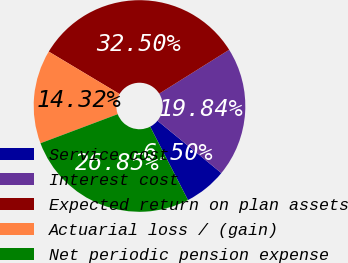Convert chart to OTSL. <chart><loc_0><loc_0><loc_500><loc_500><pie_chart><fcel>Service cost<fcel>Interest cost<fcel>Expected return on plan assets<fcel>Actuarial loss / (gain)<fcel>Net periodic pension expense<nl><fcel>6.5%<fcel>19.84%<fcel>32.5%<fcel>14.32%<fcel>26.85%<nl></chart> 